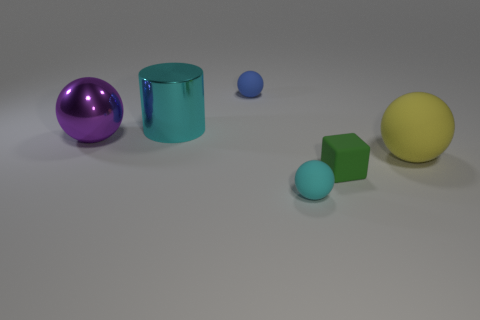There is a cylinder that is the same size as the yellow thing; what material is it?
Offer a terse response. Metal. What material is the big cyan object?
Make the answer very short. Metal. There is a cyan metallic object; is its shape the same as the big thing right of the cyan rubber thing?
Your response must be concise. No. Are there fewer tiny cyan objects behind the shiny cylinder than balls that are behind the green rubber block?
Provide a short and direct response. Yes. There is a blue thing that is the same shape as the tiny cyan rubber thing; what material is it?
Offer a terse response. Rubber. The object that is the same material as the large purple ball is what shape?
Provide a short and direct response. Cylinder. How many yellow rubber objects have the same shape as the purple metallic thing?
Make the answer very short. 1. What is the shape of the cyan object that is behind the big object that is right of the cyan cylinder?
Offer a terse response. Cylinder. There is a cyan thing that is on the left side of the cyan rubber thing; is its size the same as the purple shiny sphere?
Provide a short and direct response. Yes. There is a rubber object that is in front of the big metallic cylinder and behind the green rubber block; how big is it?
Offer a very short reply. Large. 